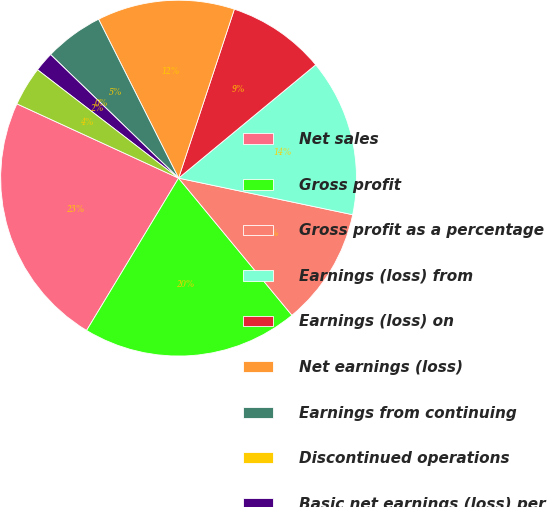<chart> <loc_0><loc_0><loc_500><loc_500><pie_chart><fcel>Net sales<fcel>Gross profit<fcel>Gross profit as a percentage<fcel>Earnings (loss) from<fcel>Earnings (loss) on<fcel>Net earnings (loss)<fcel>Earnings from continuing<fcel>Discontinued operations<fcel>Basic net earnings (loss) per<fcel>Diluted net earnings (loss)<nl><fcel>23.21%<fcel>19.64%<fcel>10.71%<fcel>14.29%<fcel>8.93%<fcel>12.5%<fcel>5.36%<fcel>0.0%<fcel>1.79%<fcel>3.57%<nl></chart> 